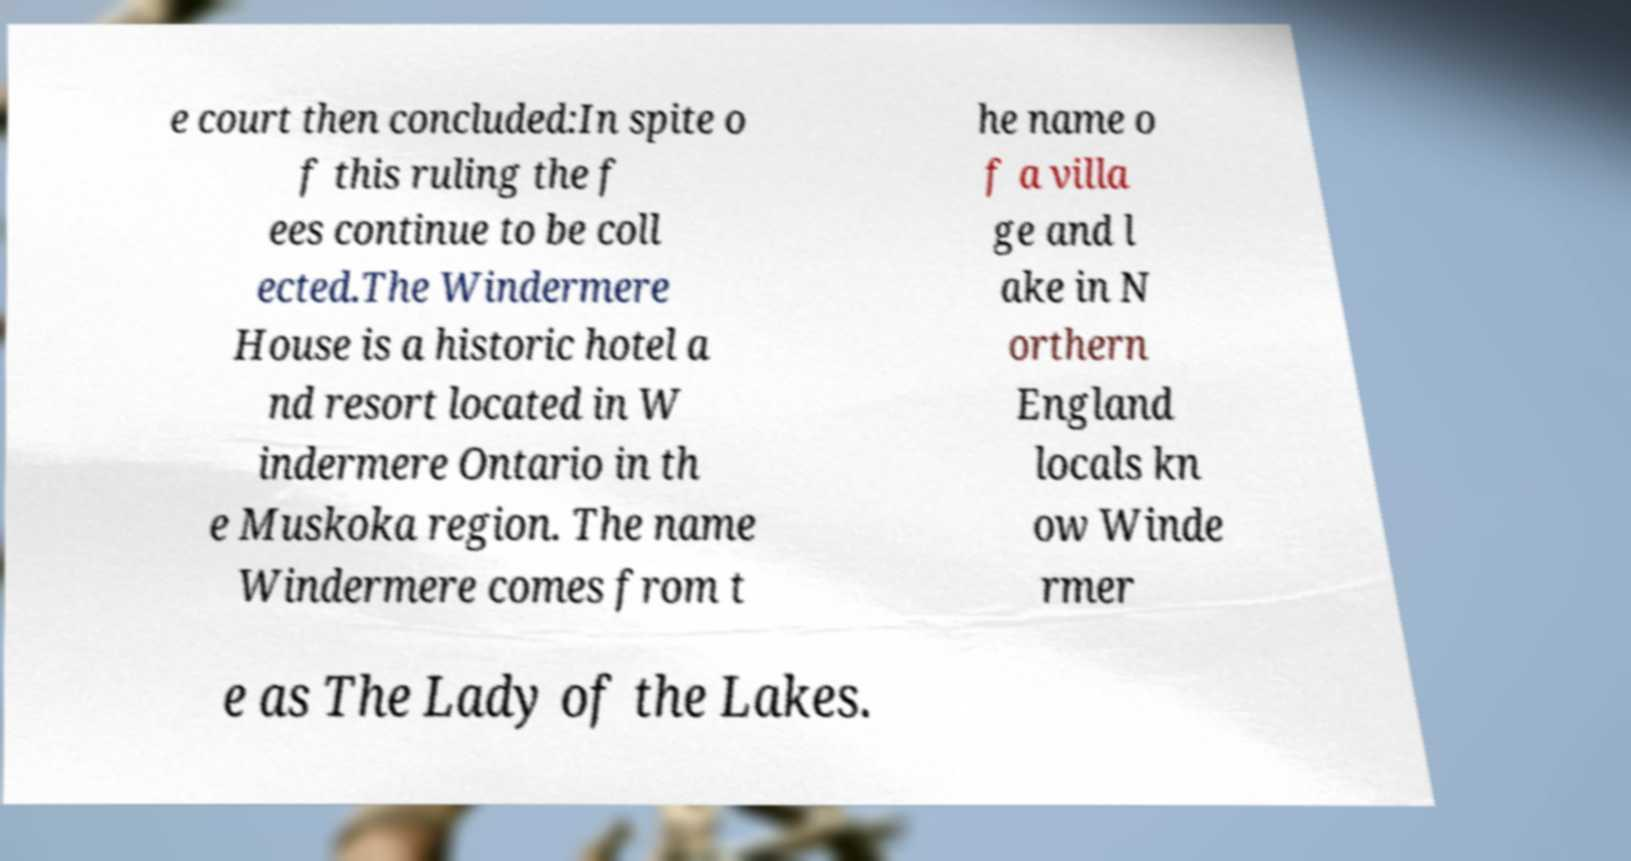Can you accurately transcribe the text from the provided image for me? e court then concluded:In spite o f this ruling the f ees continue to be coll ected.The Windermere House is a historic hotel a nd resort located in W indermere Ontario in th e Muskoka region. The name Windermere comes from t he name o f a villa ge and l ake in N orthern England locals kn ow Winde rmer e as The Lady of the Lakes. 